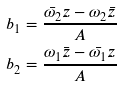<formula> <loc_0><loc_0><loc_500><loc_500>b _ { 1 } & = \frac { \bar { \omega _ { 2 } } z - \omega _ { 2 } \bar { z } } { A } \\ b _ { 2 } & = \frac { \omega _ { 1 } \bar { z } - \bar { \omega _ { 1 } } z } { A }</formula> 